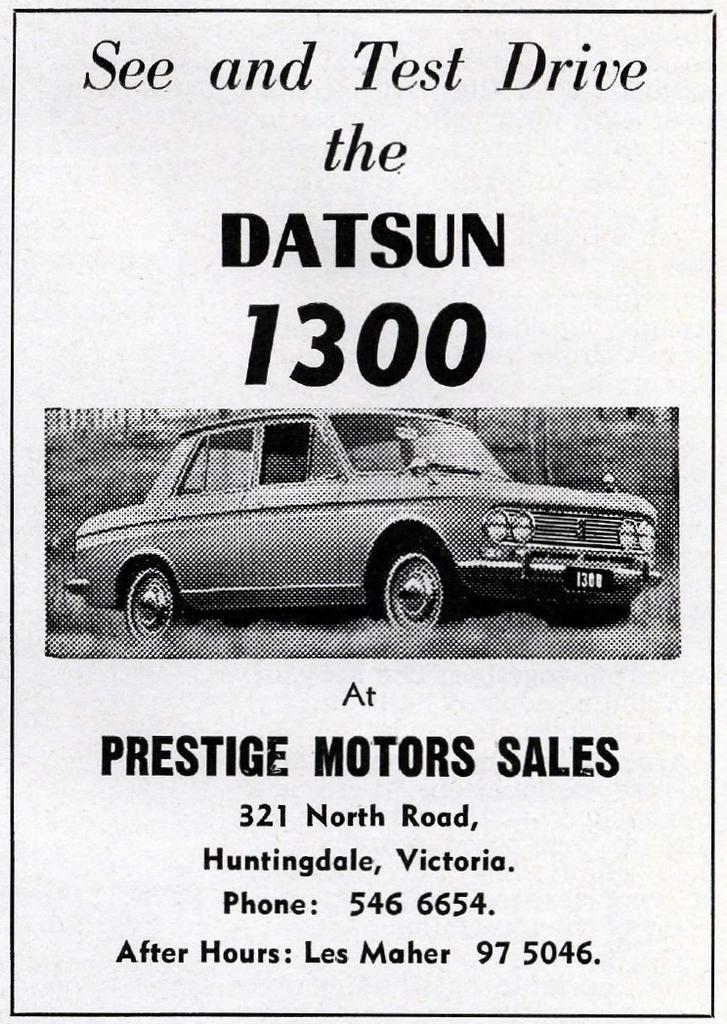What is featured in the picture? There is a poster in the picture. What can be found on the poster? The poster contains text and a picture of a car. What part of the car is shown in the picture? There is no specific part of the car shown in the picture; it is a full image of a car. How does the poster blow in the wind in the image? The poster does not blow in the wind in the image; it is stationary on a surface. 